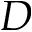<formula> <loc_0><loc_0><loc_500><loc_500>D</formula> 